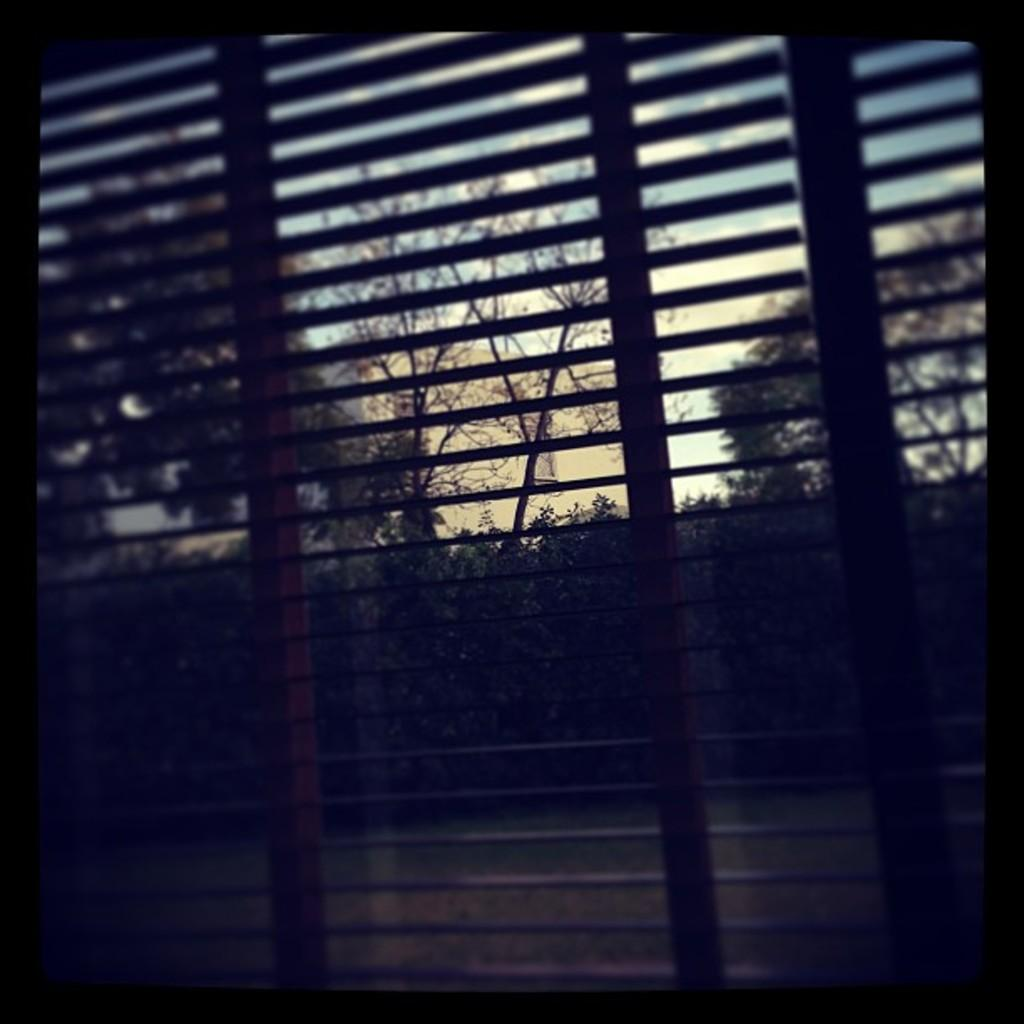What can be seen through the window in the image? There are trees visible through the window in the image. What type of vegetation is present in the image? There is grass in the image. What is visible in the background of the image? The sky is visible in the image. Can you determine the time of day based on the image? Yes, the image appears to be taken during the day. How is the image presented? The image has a photo frame appearance. What type of fuel is being used by the trees in the image? There is no indication of any fuel being used by the trees in the image; they are simply growing in their natural environment. What type of apparel is being worn by the grass in the image? There is no apparel present in the image, as grass is a plant and does not wear clothing. 